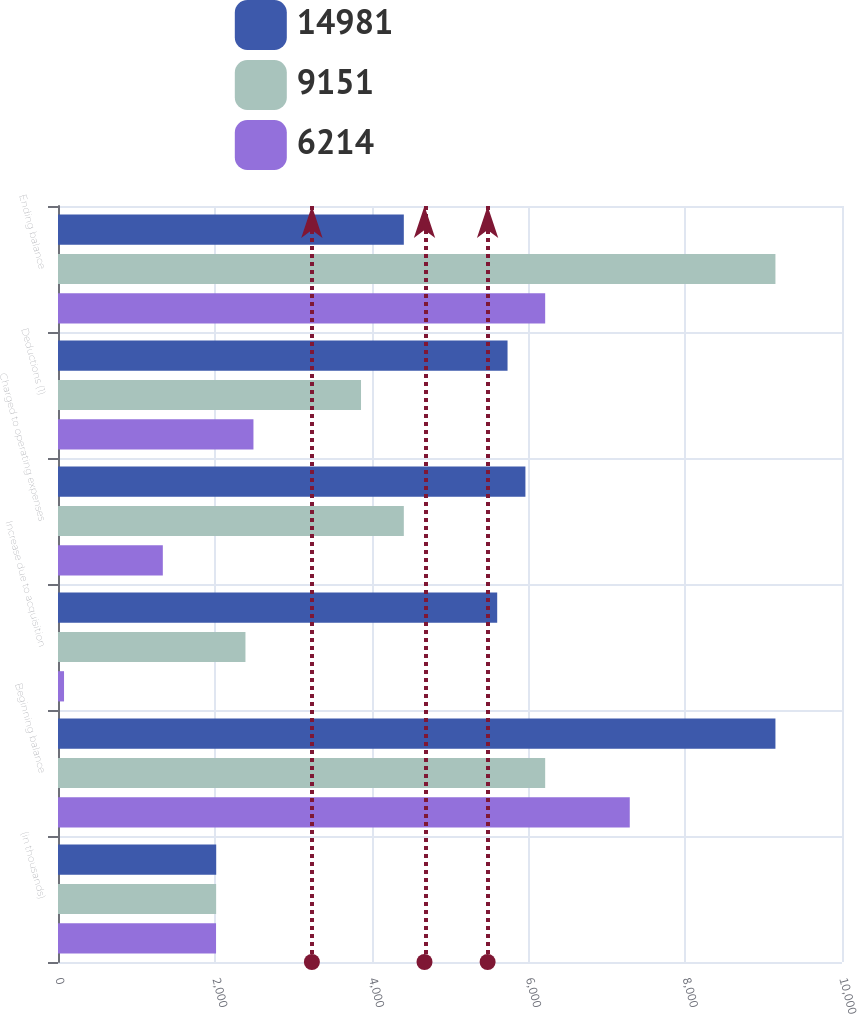Convert chart to OTSL. <chart><loc_0><loc_0><loc_500><loc_500><stacked_bar_chart><ecel><fcel>(in thousands)<fcel>Beginning balance<fcel>Increase due to acquisition<fcel>Charged to operating expenses<fcel>Deductions (1)<fcel>Ending balance<nl><fcel>14981<fcel>2018<fcel>9151<fcel>5602<fcel>5962<fcel>5734<fcel>4411<nl><fcel>9151<fcel>2017<fcel>6214<fcel>2391<fcel>4411<fcel>3865<fcel>9151<nl><fcel>6214<fcel>2016<fcel>7293<fcel>77<fcel>1337<fcel>2493<fcel>6214<nl></chart> 